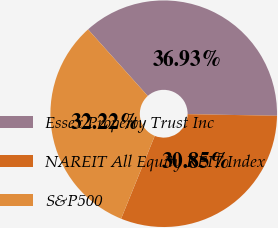Convert chart. <chart><loc_0><loc_0><loc_500><loc_500><pie_chart><fcel>Essex Property Trust Inc<fcel>NAREIT All Equity REIT Index<fcel>S&P500<nl><fcel>36.93%<fcel>30.85%<fcel>32.22%<nl></chart> 